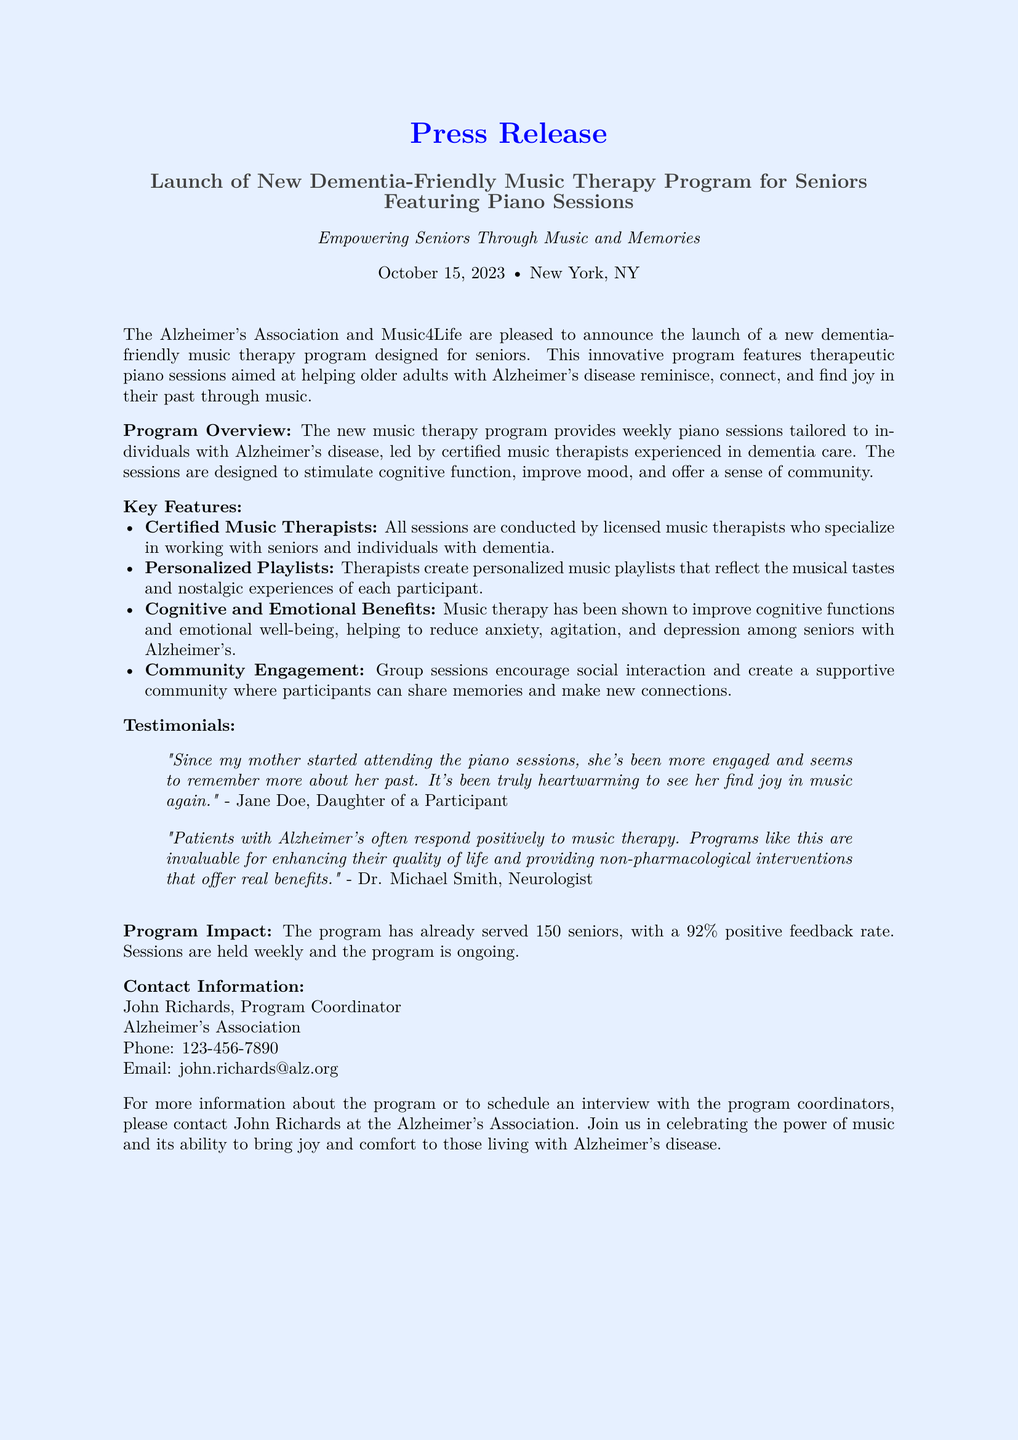What is the name of the program? The program is referred to as the "dementia-friendly music therapy program."
Answer: dementia-friendly music therapy program Who organized the program? The program is organized by the Alzheimer's Association and Music4Life.
Answer: Alzheimer's Association and Music4Life When was the program launched? The program was launched on October 15, 2023.
Answer: October 15, 2023 What percentage of positive feedback has the program received? The program has received a 92% positive feedback rate.
Answer: 92% Who leads the piano sessions? The piano sessions are led by certified music therapists.
Answer: certified music therapists What is one of the emotional benefits of music therapy mentioned in the document? One of the emotional benefits is that music therapy helps to reduce anxiety among seniors with Alzheimer's.
Answer: reduce anxiety How many seniors have been served by the program so far? The program has served 150 seniors.
Answer: 150 What type of intervention does the program provide? The program provides non-pharmacological interventions.
Answer: non-pharmacological interventions Who can be contacted for more information about the program? John Richards can be contacted for more information.
Answer: John Richards 